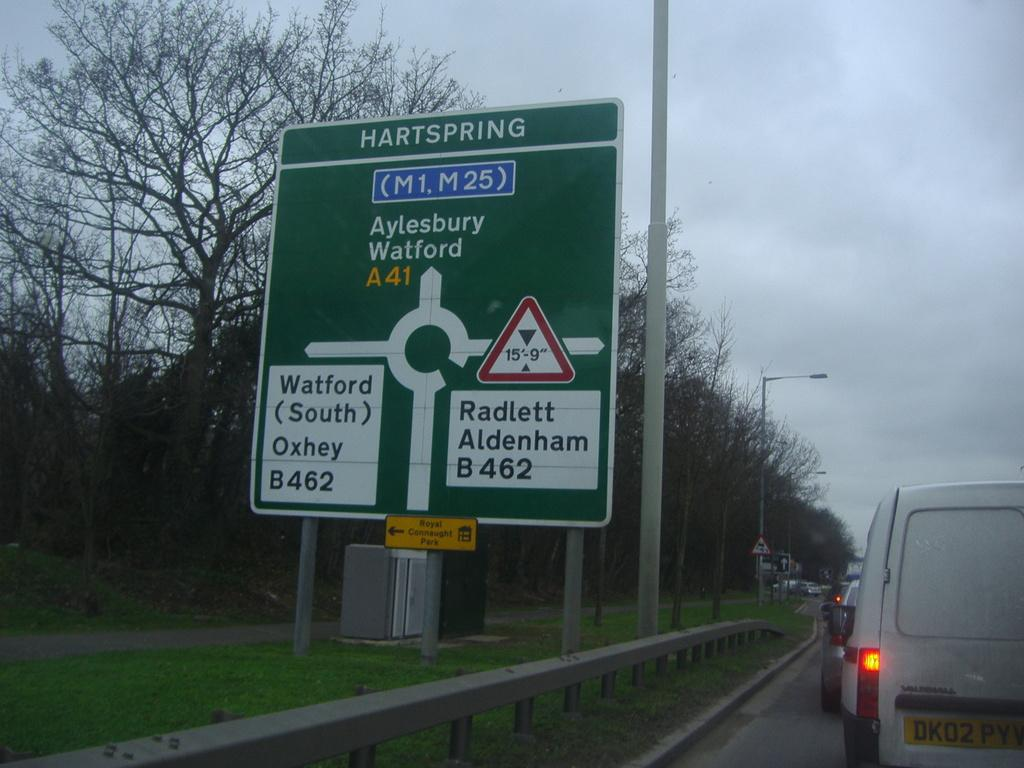<image>
Give a short and clear explanation of the subsequent image. A sign next to the road shows directions to Watford, Aylesbury Watford, and Radlett Aldenham. 